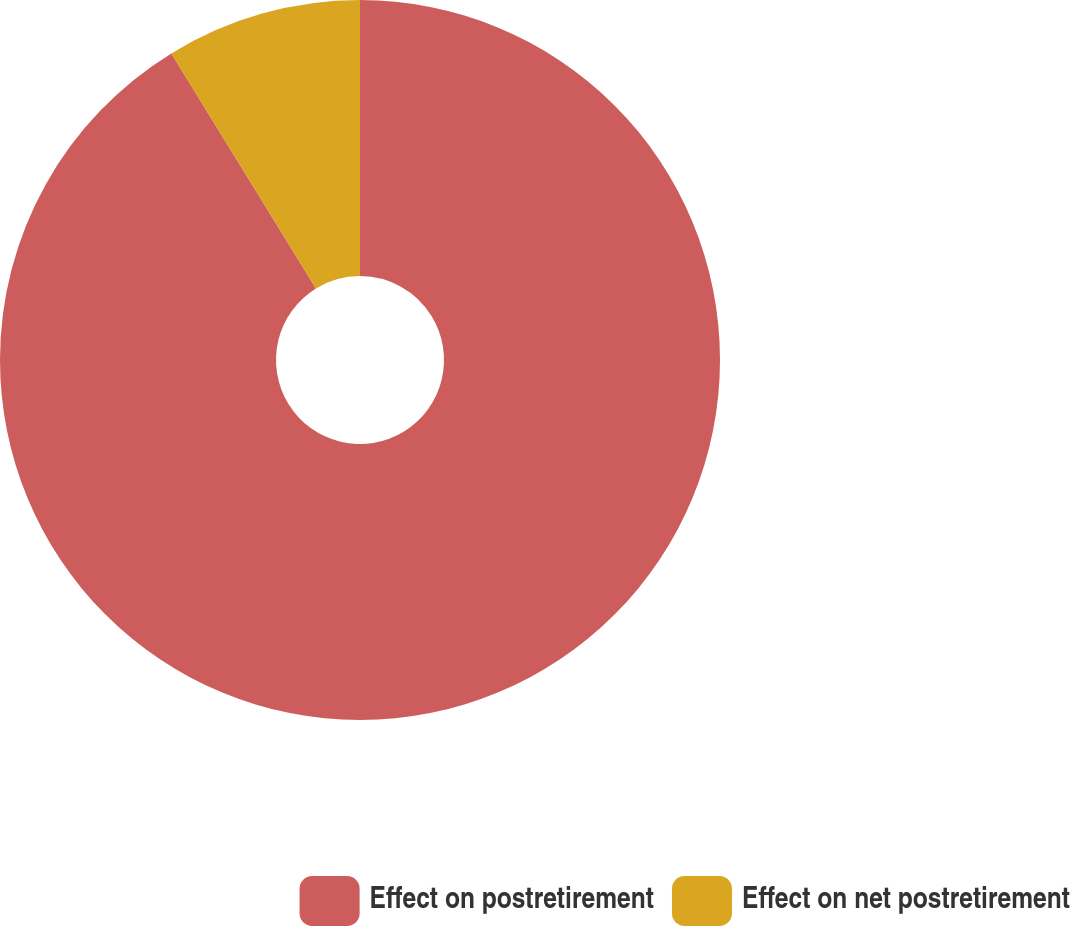<chart> <loc_0><loc_0><loc_500><loc_500><pie_chart><fcel>Effect on postretirement<fcel>Effect on net postretirement<nl><fcel>91.22%<fcel>8.78%<nl></chart> 